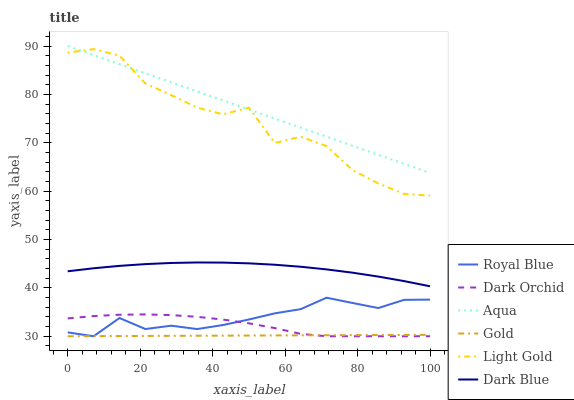Does Dark Blue have the minimum area under the curve?
Answer yes or no. No. Does Dark Blue have the maximum area under the curve?
Answer yes or no. No. Is Dark Blue the smoothest?
Answer yes or no. No. Is Dark Blue the roughest?
Answer yes or no. No. Does Dark Blue have the lowest value?
Answer yes or no. No. Does Dark Blue have the highest value?
Answer yes or no. No. Is Dark Orchid less than Dark Blue?
Answer yes or no. Yes. Is Light Gold greater than Dark Orchid?
Answer yes or no. Yes. Does Dark Orchid intersect Dark Blue?
Answer yes or no. No. 